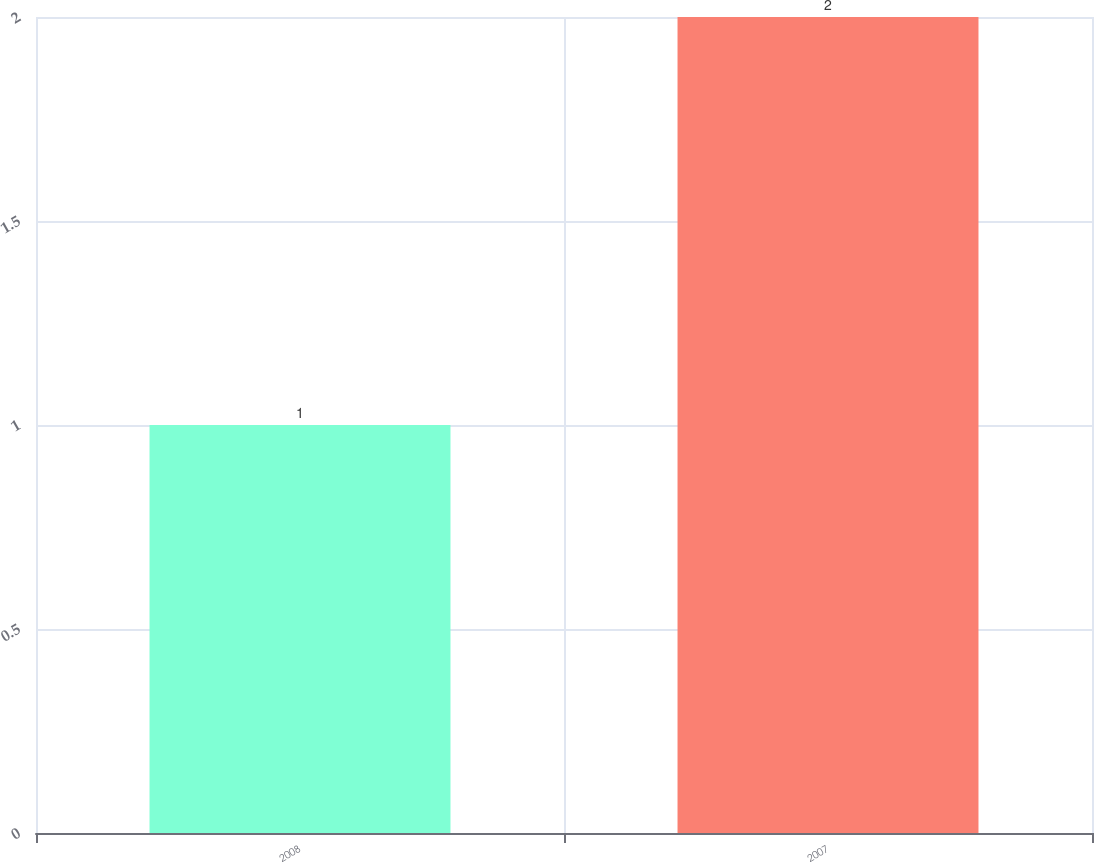Convert chart. <chart><loc_0><loc_0><loc_500><loc_500><bar_chart><fcel>2008<fcel>2007<nl><fcel>1<fcel>2<nl></chart> 